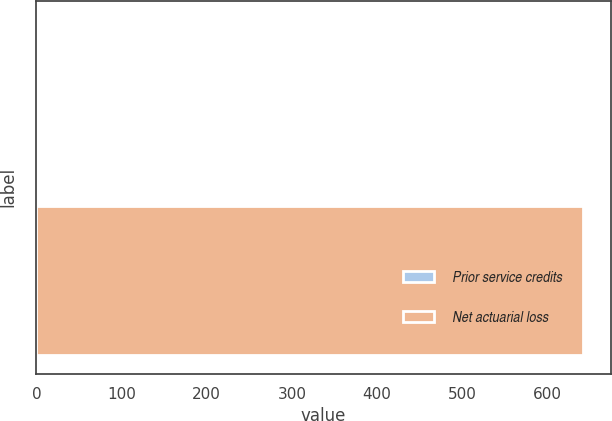<chart> <loc_0><loc_0><loc_500><loc_500><bar_chart><fcel>Prior service credits<fcel>Net actuarial loss<nl><fcel>2<fcel>642<nl></chart> 